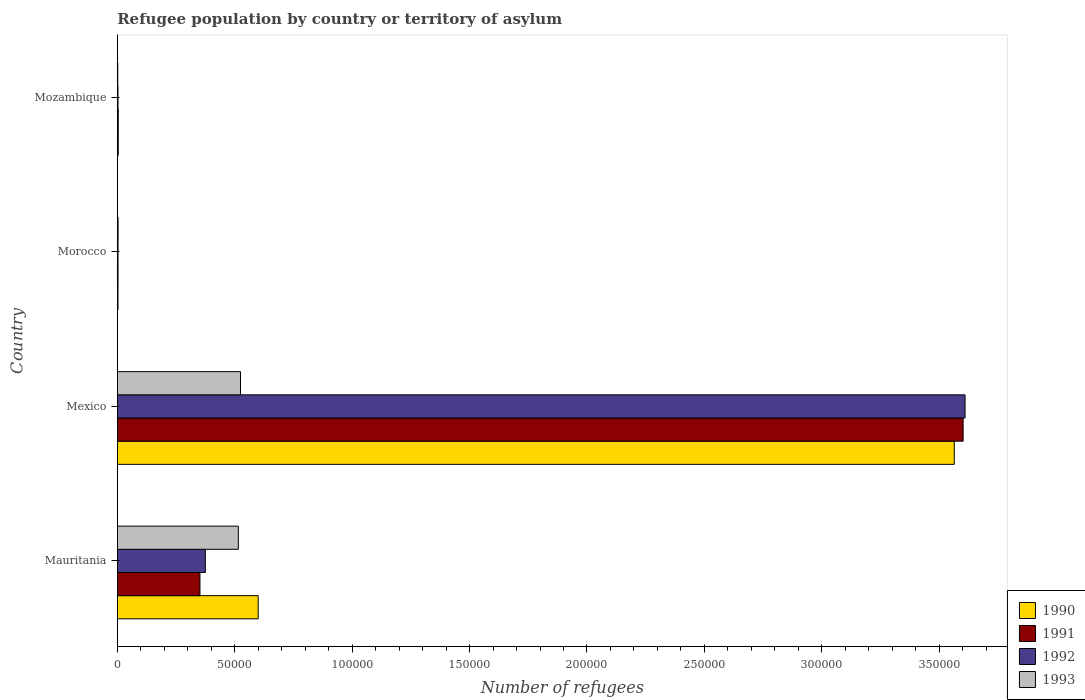How many groups of bars are there?
Your response must be concise. 4. Are the number of bars on each tick of the Y-axis equal?
Your response must be concise. Yes. What is the label of the 1st group of bars from the top?
Give a very brief answer. Mozambique. In how many cases, is the number of bars for a given country not equal to the number of legend labels?
Provide a short and direct response. 0. What is the number of refugees in 1990 in Mozambique?
Provide a succinct answer. 420. Across all countries, what is the maximum number of refugees in 1991?
Keep it short and to the point. 3.60e+05. Across all countries, what is the minimum number of refugees in 1993?
Keep it short and to the point. 202. In which country was the number of refugees in 1991 minimum?
Keep it short and to the point. Morocco. What is the total number of refugees in 1990 in the graph?
Your answer should be compact. 4.17e+05. What is the difference between the number of refugees in 1993 in Mauritania and that in Mexico?
Give a very brief answer. -929. What is the difference between the number of refugees in 1991 in Morocco and the number of refugees in 1992 in Mauritania?
Give a very brief answer. -3.72e+04. What is the average number of refugees in 1991 per country?
Your answer should be compact. 9.90e+04. What is the difference between the number of refugees in 1991 and number of refugees in 1990 in Mauritania?
Offer a very short reply. -2.48e+04. What is the ratio of the number of refugees in 1991 in Mauritania to that in Mexico?
Offer a terse response. 0.1. What is the difference between the highest and the second highest number of refugees in 1990?
Give a very brief answer. 2.96e+05. What is the difference between the highest and the lowest number of refugees in 1993?
Offer a very short reply. 5.23e+04. Is the sum of the number of refugees in 1992 in Mauritania and Morocco greater than the maximum number of refugees in 1993 across all countries?
Ensure brevity in your answer.  No. Is it the case that in every country, the sum of the number of refugees in 1993 and number of refugees in 1992 is greater than the sum of number of refugees in 1990 and number of refugees in 1991?
Provide a succinct answer. No. Is it the case that in every country, the sum of the number of refugees in 1990 and number of refugees in 1991 is greater than the number of refugees in 1993?
Provide a succinct answer. Yes. How many bars are there?
Your response must be concise. 16. Are all the bars in the graph horizontal?
Provide a short and direct response. Yes. How many countries are there in the graph?
Offer a terse response. 4. Are the values on the major ticks of X-axis written in scientific E-notation?
Keep it short and to the point. No. Does the graph contain grids?
Your answer should be compact. No. How are the legend labels stacked?
Your response must be concise. Vertical. What is the title of the graph?
Your answer should be very brief. Refugee population by country or territory of asylum. What is the label or title of the X-axis?
Ensure brevity in your answer.  Number of refugees. What is the label or title of the Y-axis?
Give a very brief answer. Country. What is the Number of refugees in 1990 in Mauritania?
Give a very brief answer. 6.00e+04. What is the Number of refugees in 1991 in Mauritania?
Ensure brevity in your answer.  3.52e+04. What is the Number of refugees of 1992 in Mauritania?
Offer a very short reply. 3.75e+04. What is the Number of refugees in 1993 in Mauritania?
Your answer should be very brief. 5.15e+04. What is the Number of refugees of 1990 in Mexico?
Your response must be concise. 3.56e+05. What is the Number of refugees in 1991 in Mexico?
Your answer should be very brief. 3.60e+05. What is the Number of refugees in 1992 in Mexico?
Offer a very short reply. 3.61e+05. What is the Number of refugees in 1993 in Mexico?
Your response must be concise. 5.25e+04. What is the Number of refugees in 1990 in Morocco?
Provide a short and direct response. 311. What is the Number of refugees in 1991 in Morocco?
Keep it short and to the point. 322. What is the Number of refugees of 1992 in Morocco?
Your answer should be compact. 319. What is the Number of refugees in 1993 in Morocco?
Your answer should be very brief. 336. What is the Number of refugees of 1990 in Mozambique?
Ensure brevity in your answer.  420. What is the Number of refugees in 1991 in Mozambique?
Offer a very short reply. 420. What is the Number of refugees of 1992 in Mozambique?
Your response must be concise. 299. What is the Number of refugees in 1993 in Mozambique?
Provide a short and direct response. 202. Across all countries, what is the maximum Number of refugees in 1990?
Provide a succinct answer. 3.56e+05. Across all countries, what is the maximum Number of refugees of 1991?
Keep it short and to the point. 3.60e+05. Across all countries, what is the maximum Number of refugees in 1992?
Your answer should be compact. 3.61e+05. Across all countries, what is the maximum Number of refugees of 1993?
Provide a succinct answer. 5.25e+04. Across all countries, what is the minimum Number of refugees of 1990?
Offer a very short reply. 311. Across all countries, what is the minimum Number of refugees of 1991?
Make the answer very short. 322. Across all countries, what is the minimum Number of refugees in 1992?
Ensure brevity in your answer.  299. Across all countries, what is the minimum Number of refugees in 1993?
Make the answer very short. 202. What is the total Number of refugees of 1990 in the graph?
Keep it short and to the point. 4.17e+05. What is the total Number of refugees in 1991 in the graph?
Offer a terse response. 3.96e+05. What is the total Number of refugees in 1992 in the graph?
Your answer should be compact. 3.99e+05. What is the total Number of refugees of 1993 in the graph?
Offer a terse response. 1.05e+05. What is the difference between the Number of refugees in 1990 in Mauritania and that in Mexico?
Offer a terse response. -2.96e+05. What is the difference between the Number of refugees in 1991 in Mauritania and that in Mexico?
Make the answer very short. -3.25e+05. What is the difference between the Number of refugees of 1992 in Mauritania and that in Mexico?
Your answer should be compact. -3.23e+05. What is the difference between the Number of refugees in 1993 in Mauritania and that in Mexico?
Make the answer very short. -929. What is the difference between the Number of refugees in 1990 in Mauritania and that in Morocco?
Offer a terse response. 5.97e+04. What is the difference between the Number of refugees of 1991 in Mauritania and that in Morocco?
Your answer should be compact. 3.49e+04. What is the difference between the Number of refugees in 1992 in Mauritania and that in Morocco?
Your answer should be compact. 3.72e+04. What is the difference between the Number of refugees in 1993 in Mauritania and that in Morocco?
Offer a terse response. 5.12e+04. What is the difference between the Number of refugees of 1990 in Mauritania and that in Mozambique?
Make the answer very short. 5.96e+04. What is the difference between the Number of refugees of 1991 in Mauritania and that in Mozambique?
Your answer should be compact. 3.48e+04. What is the difference between the Number of refugees in 1992 in Mauritania and that in Mozambique?
Make the answer very short. 3.72e+04. What is the difference between the Number of refugees of 1993 in Mauritania and that in Mozambique?
Provide a short and direct response. 5.13e+04. What is the difference between the Number of refugees in 1990 in Mexico and that in Morocco?
Your answer should be compact. 3.56e+05. What is the difference between the Number of refugees in 1991 in Mexico and that in Morocco?
Provide a short and direct response. 3.60e+05. What is the difference between the Number of refugees in 1992 in Mexico and that in Morocco?
Offer a terse response. 3.61e+05. What is the difference between the Number of refugees in 1993 in Mexico and that in Morocco?
Keep it short and to the point. 5.21e+04. What is the difference between the Number of refugees in 1990 in Mexico and that in Mozambique?
Offer a terse response. 3.56e+05. What is the difference between the Number of refugees of 1991 in Mexico and that in Mozambique?
Your response must be concise. 3.60e+05. What is the difference between the Number of refugees of 1992 in Mexico and that in Mozambique?
Your response must be concise. 3.61e+05. What is the difference between the Number of refugees of 1993 in Mexico and that in Mozambique?
Your answer should be very brief. 5.23e+04. What is the difference between the Number of refugees in 1990 in Morocco and that in Mozambique?
Ensure brevity in your answer.  -109. What is the difference between the Number of refugees in 1991 in Morocco and that in Mozambique?
Keep it short and to the point. -98. What is the difference between the Number of refugees of 1992 in Morocco and that in Mozambique?
Your response must be concise. 20. What is the difference between the Number of refugees of 1993 in Morocco and that in Mozambique?
Make the answer very short. 134. What is the difference between the Number of refugees in 1990 in Mauritania and the Number of refugees in 1991 in Mexico?
Provide a succinct answer. -3.00e+05. What is the difference between the Number of refugees in 1990 in Mauritania and the Number of refugees in 1992 in Mexico?
Your response must be concise. -3.01e+05. What is the difference between the Number of refugees of 1990 in Mauritania and the Number of refugees of 1993 in Mexico?
Provide a short and direct response. 7523. What is the difference between the Number of refugees in 1991 in Mauritania and the Number of refugees in 1992 in Mexico?
Provide a short and direct response. -3.26e+05. What is the difference between the Number of refugees of 1991 in Mauritania and the Number of refugees of 1993 in Mexico?
Keep it short and to the point. -1.73e+04. What is the difference between the Number of refugees in 1992 in Mauritania and the Number of refugees in 1993 in Mexico?
Provide a short and direct response. -1.50e+04. What is the difference between the Number of refugees in 1990 in Mauritania and the Number of refugees in 1991 in Morocco?
Offer a terse response. 5.97e+04. What is the difference between the Number of refugees in 1990 in Mauritania and the Number of refugees in 1992 in Morocco?
Provide a succinct answer. 5.97e+04. What is the difference between the Number of refugees in 1990 in Mauritania and the Number of refugees in 1993 in Morocco?
Offer a terse response. 5.97e+04. What is the difference between the Number of refugees in 1991 in Mauritania and the Number of refugees in 1992 in Morocco?
Provide a succinct answer. 3.49e+04. What is the difference between the Number of refugees of 1991 in Mauritania and the Number of refugees of 1993 in Morocco?
Ensure brevity in your answer.  3.49e+04. What is the difference between the Number of refugees of 1992 in Mauritania and the Number of refugees of 1993 in Morocco?
Give a very brief answer. 3.72e+04. What is the difference between the Number of refugees of 1990 in Mauritania and the Number of refugees of 1991 in Mozambique?
Your answer should be very brief. 5.96e+04. What is the difference between the Number of refugees of 1990 in Mauritania and the Number of refugees of 1992 in Mozambique?
Make the answer very short. 5.97e+04. What is the difference between the Number of refugees in 1990 in Mauritania and the Number of refugees in 1993 in Mozambique?
Provide a short and direct response. 5.98e+04. What is the difference between the Number of refugees in 1991 in Mauritania and the Number of refugees in 1992 in Mozambique?
Your answer should be compact. 3.49e+04. What is the difference between the Number of refugees of 1991 in Mauritania and the Number of refugees of 1993 in Mozambique?
Keep it short and to the point. 3.50e+04. What is the difference between the Number of refugees of 1992 in Mauritania and the Number of refugees of 1993 in Mozambique?
Ensure brevity in your answer.  3.73e+04. What is the difference between the Number of refugees of 1990 in Mexico and the Number of refugees of 1991 in Morocco?
Provide a succinct answer. 3.56e+05. What is the difference between the Number of refugees of 1990 in Mexico and the Number of refugees of 1992 in Morocco?
Offer a terse response. 3.56e+05. What is the difference between the Number of refugees of 1990 in Mexico and the Number of refugees of 1993 in Morocco?
Offer a terse response. 3.56e+05. What is the difference between the Number of refugees in 1991 in Mexico and the Number of refugees in 1992 in Morocco?
Give a very brief answer. 3.60e+05. What is the difference between the Number of refugees in 1991 in Mexico and the Number of refugees in 1993 in Morocco?
Ensure brevity in your answer.  3.60e+05. What is the difference between the Number of refugees of 1992 in Mexico and the Number of refugees of 1993 in Morocco?
Provide a short and direct response. 3.61e+05. What is the difference between the Number of refugees of 1990 in Mexico and the Number of refugees of 1991 in Mozambique?
Offer a very short reply. 3.56e+05. What is the difference between the Number of refugees in 1990 in Mexico and the Number of refugees in 1992 in Mozambique?
Ensure brevity in your answer.  3.56e+05. What is the difference between the Number of refugees of 1990 in Mexico and the Number of refugees of 1993 in Mozambique?
Give a very brief answer. 3.56e+05. What is the difference between the Number of refugees in 1991 in Mexico and the Number of refugees in 1992 in Mozambique?
Your answer should be very brief. 3.60e+05. What is the difference between the Number of refugees in 1991 in Mexico and the Number of refugees in 1993 in Mozambique?
Keep it short and to the point. 3.60e+05. What is the difference between the Number of refugees of 1992 in Mexico and the Number of refugees of 1993 in Mozambique?
Provide a succinct answer. 3.61e+05. What is the difference between the Number of refugees of 1990 in Morocco and the Number of refugees of 1991 in Mozambique?
Your answer should be very brief. -109. What is the difference between the Number of refugees in 1990 in Morocco and the Number of refugees in 1992 in Mozambique?
Offer a very short reply. 12. What is the difference between the Number of refugees in 1990 in Morocco and the Number of refugees in 1993 in Mozambique?
Ensure brevity in your answer.  109. What is the difference between the Number of refugees in 1991 in Morocco and the Number of refugees in 1992 in Mozambique?
Your answer should be compact. 23. What is the difference between the Number of refugees of 1991 in Morocco and the Number of refugees of 1993 in Mozambique?
Give a very brief answer. 120. What is the difference between the Number of refugees of 1992 in Morocco and the Number of refugees of 1993 in Mozambique?
Keep it short and to the point. 117. What is the average Number of refugees of 1990 per country?
Offer a terse response. 1.04e+05. What is the average Number of refugees in 1991 per country?
Offer a very short reply. 9.90e+04. What is the average Number of refugees in 1992 per country?
Your response must be concise. 9.98e+04. What is the average Number of refugees in 1993 per country?
Your response must be concise. 2.61e+04. What is the difference between the Number of refugees of 1990 and Number of refugees of 1991 in Mauritania?
Make the answer very short. 2.48e+04. What is the difference between the Number of refugees of 1990 and Number of refugees of 1992 in Mauritania?
Give a very brief answer. 2.25e+04. What is the difference between the Number of refugees of 1990 and Number of refugees of 1993 in Mauritania?
Your answer should be very brief. 8452. What is the difference between the Number of refugees in 1991 and Number of refugees in 1992 in Mauritania?
Ensure brevity in your answer.  -2300. What is the difference between the Number of refugees in 1991 and Number of refugees in 1993 in Mauritania?
Provide a short and direct response. -1.63e+04. What is the difference between the Number of refugees in 1992 and Number of refugees in 1993 in Mauritania?
Provide a short and direct response. -1.40e+04. What is the difference between the Number of refugees in 1990 and Number of refugees in 1991 in Mexico?
Offer a very short reply. -3770. What is the difference between the Number of refugees in 1990 and Number of refugees in 1992 in Mexico?
Provide a short and direct response. -4591. What is the difference between the Number of refugees of 1990 and Number of refugees of 1993 in Mexico?
Provide a short and direct response. 3.04e+05. What is the difference between the Number of refugees of 1991 and Number of refugees of 1992 in Mexico?
Your answer should be compact. -821. What is the difference between the Number of refugees in 1991 and Number of refugees in 1993 in Mexico?
Keep it short and to the point. 3.08e+05. What is the difference between the Number of refugees in 1992 and Number of refugees in 1993 in Mexico?
Make the answer very short. 3.09e+05. What is the difference between the Number of refugees of 1990 and Number of refugees of 1991 in Morocco?
Keep it short and to the point. -11. What is the difference between the Number of refugees of 1990 and Number of refugees of 1992 in Morocco?
Make the answer very short. -8. What is the difference between the Number of refugees of 1990 and Number of refugees of 1993 in Morocco?
Provide a short and direct response. -25. What is the difference between the Number of refugees in 1992 and Number of refugees in 1993 in Morocco?
Keep it short and to the point. -17. What is the difference between the Number of refugees in 1990 and Number of refugees in 1991 in Mozambique?
Offer a terse response. 0. What is the difference between the Number of refugees in 1990 and Number of refugees in 1992 in Mozambique?
Make the answer very short. 121. What is the difference between the Number of refugees in 1990 and Number of refugees in 1993 in Mozambique?
Ensure brevity in your answer.  218. What is the difference between the Number of refugees in 1991 and Number of refugees in 1992 in Mozambique?
Your response must be concise. 121. What is the difference between the Number of refugees in 1991 and Number of refugees in 1993 in Mozambique?
Your response must be concise. 218. What is the difference between the Number of refugees in 1992 and Number of refugees in 1993 in Mozambique?
Your response must be concise. 97. What is the ratio of the Number of refugees of 1990 in Mauritania to that in Mexico?
Your answer should be compact. 0.17. What is the ratio of the Number of refugees in 1991 in Mauritania to that in Mexico?
Your response must be concise. 0.1. What is the ratio of the Number of refugees of 1992 in Mauritania to that in Mexico?
Give a very brief answer. 0.1. What is the ratio of the Number of refugees of 1993 in Mauritania to that in Mexico?
Your answer should be compact. 0.98. What is the ratio of the Number of refugees in 1990 in Mauritania to that in Morocco?
Offer a very short reply. 192.93. What is the ratio of the Number of refugees of 1991 in Mauritania to that in Morocco?
Offer a terse response. 109.32. What is the ratio of the Number of refugees in 1992 in Mauritania to that in Morocco?
Offer a terse response. 117.55. What is the ratio of the Number of refugees in 1993 in Mauritania to that in Morocco?
Your response must be concise. 153.42. What is the ratio of the Number of refugees of 1990 in Mauritania to that in Mozambique?
Offer a terse response. 142.86. What is the ratio of the Number of refugees of 1991 in Mauritania to that in Mozambique?
Give a very brief answer. 83.81. What is the ratio of the Number of refugees of 1992 in Mauritania to that in Mozambique?
Provide a short and direct response. 125.42. What is the ratio of the Number of refugees in 1993 in Mauritania to that in Mozambique?
Ensure brevity in your answer.  255.19. What is the ratio of the Number of refugees of 1990 in Mexico to that in Morocco?
Make the answer very short. 1145.98. What is the ratio of the Number of refugees in 1991 in Mexico to that in Morocco?
Keep it short and to the point. 1118.54. What is the ratio of the Number of refugees in 1992 in Mexico to that in Morocco?
Keep it short and to the point. 1131.63. What is the ratio of the Number of refugees in 1993 in Mexico to that in Morocco?
Offer a very short reply. 156.18. What is the ratio of the Number of refugees of 1990 in Mexico to that in Mozambique?
Provide a short and direct response. 848.57. What is the ratio of the Number of refugees in 1991 in Mexico to that in Mozambique?
Provide a succinct answer. 857.55. What is the ratio of the Number of refugees of 1992 in Mexico to that in Mozambique?
Make the answer very short. 1207.33. What is the ratio of the Number of refugees of 1993 in Mexico to that in Mozambique?
Keep it short and to the point. 259.79. What is the ratio of the Number of refugees in 1990 in Morocco to that in Mozambique?
Make the answer very short. 0.74. What is the ratio of the Number of refugees in 1991 in Morocco to that in Mozambique?
Provide a short and direct response. 0.77. What is the ratio of the Number of refugees in 1992 in Morocco to that in Mozambique?
Your answer should be compact. 1.07. What is the ratio of the Number of refugees in 1993 in Morocco to that in Mozambique?
Your response must be concise. 1.66. What is the difference between the highest and the second highest Number of refugees of 1990?
Provide a short and direct response. 2.96e+05. What is the difference between the highest and the second highest Number of refugees in 1991?
Ensure brevity in your answer.  3.25e+05. What is the difference between the highest and the second highest Number of refugees in 1992?
Your response must be concise. 3.23e+05. What is the difference between the highest and the second highest Number of refugees in 1993?
Your answer should be compact. 929. What is the difference between the highest and the lowest Number of refugees of 1990?
Make the answer very short. 3.56e+05. What is the difference between the highest and the lowest Number of refugees in 1991?
Ensure brevity in your answer.  3.60e+05. What is the difference between the highest and the lowest Number of refugees of 1992?
Offer a terse response. 3.61e+05. What is the difference between the highest and the lowest Number of refugees in 1993?
Make the answer very short. 5.23e+04. 